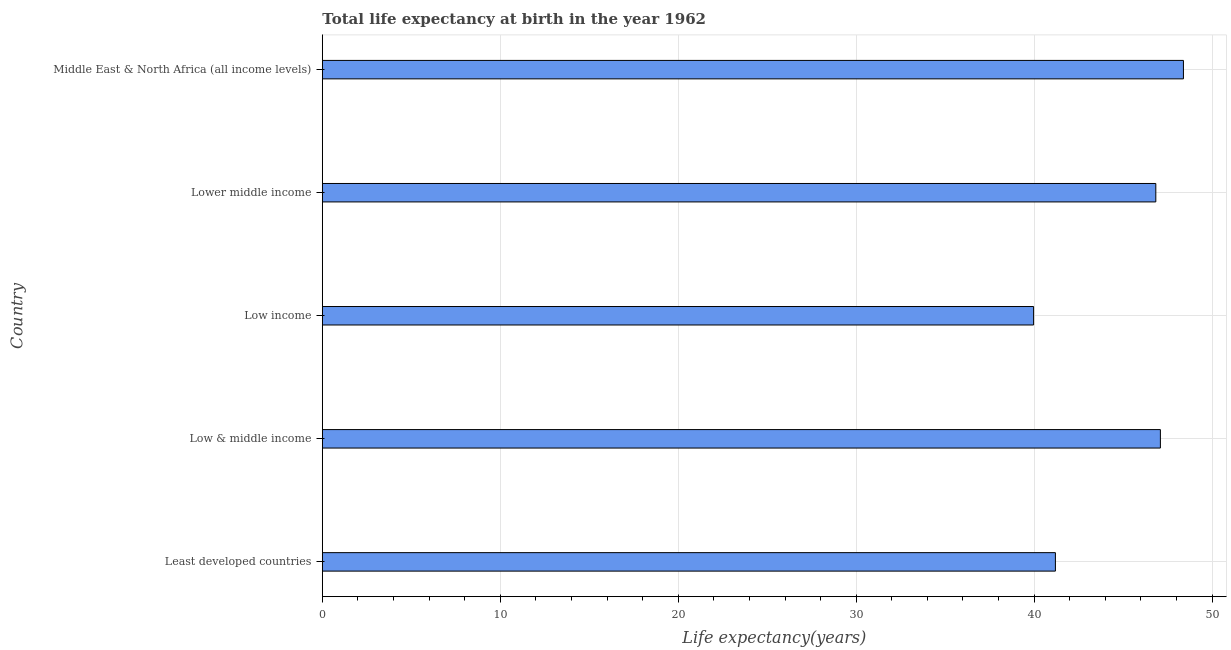Does the graph contain any zero values?
Offer a terse response. No. What is the title of the graph?
Your answer should be compact. Total life expectancy at birth in the year 1962. What is the label or title of the X-axis?
Offer a very short reply. Life expectancy(years). What is the life expectancy at birth in Middle East & North Africa (all income levels)?
Provide a short and direct response. 48.39. Across all countries, what is the maximum life expectancy at birth?
Your answer should be compact. 48.39. Across all countries, what is the minimum life expectancy at birth?
Ensure brevity in your answer.  39.97. In which country was the life expectancy at birth maximum?
Your response must be concise. Middle East & North Africa (all income levels). In which country was the life expectancy at birth minimum?
Offer a very short reply. Low income. What is the sum of the life expectancy at birth?
Your response must be concise. 223.47. What is the difference between the life expectancy at birth in Low & middle income and Middle East & North Africa (all income levels)?
Offer a very short reply. -1.29. What is the average life expectancy at birth per country?
Your answer should be very brief. 44.7. What is the median life expectancy at birth?
Your answer should be compact. 46.84. In how many countries, is the life expectancy at birth greater than 34 years?
Provide a succinct answer. 5. What is the ratio of the life expectancy at birth in Low income to that in Middle East & North Africa (all income levels)?
Keep it short and to the point. 0.83. What is the difference between the highest and the second highest life expectancy at birth?
Ensure brevity in your answer.  1.29. Is the sum of the life expectancy at birth in Low & middle income and Middle East & North Africa (all income levels) greater than the maximum life expectancy at birth across all countries?
Offer a very short reply. Yes. What is the difference between the highest and the lowest life expectancy at birth?
Offer a very short reply. 8.42. Are all the bars in the graph horizontal?
Offer a very short reply. Yes. How many countries are there in the graph?
Make the answer very short. 5. What is the difference between two consecutive major ticks on the X-axis?
Your answer should be very brief. 10. What is the Life expectancy(years) in Least developed countries?
Make the answer very short. 41.19. What is the Life expectancy(years) in Low & middle income?
Provide a succinct answer. 47.09. What is the Life expectancy(years) in Low income?
Ensure brevity in your answer.  39.97. What is the Life expectancy(years) of Lower middle income?
Give a very brief answer. 46.84. What is the Life expectancy(years) in Middle East & North Africa (all income levels)?
Provide a short and direct response. 48.39. What is the difference between the Life expectancy(years) in Least developed countries and Low & middle income?
Your answer should be very brief. -5.9. What is the difference between the Life expectancy(years) in Least developed countries and Low income?
Your answer should be very brief. 1.23. What is the difference between the Life expectancy(years) in Least developed countries and Lower middle income?
Your response must be concise. -5.64. What is the difference between the Life expectancy(years) in Least developed countries and Middle East & North Africa (all income levels)?
Give a very brief answer. -7.19. What is the difference between the Life expectancy(years) in Low & middle income and Low income?
Your answer should be very brief. 7.12. What is the difference between the Life expectancy(years) in Low & middle income and Lower middle income?
Your answer should be compact. 0.26. What is the difference between the Life expectancy(years) in Low & middle income and Middle East & North Africa (all income levels)?
Your response must be concise. -1.3. What is the difference between the Life expectancy(years) in Low income and Lower middle income?
Make the answer very short. -6.87. What is the difference between the Life expectancy(years) in Low income and Middle East & North Africa (all income levels)?
Provide a short and direct response. -8.42. What is the difference between the Life expectancy(years) in Lower middle income and Middle East & North Africa (all income levels)?
Provide a short and direct response. -1.55. What is the ratio of the Life expectancy(years) in Least developed countries to that in Low income?
Provide a short and direct response. 1.03. What is the ratio of the Life expectancy(years) in Least developed countries to that in Lower middle income?
Your answer should be compact. 0.88. What is the ratio of the Life expectancy(years) in Least developed countries to that in Middle East & North Africa (all income levels)?
Make the answer very short. 0.85. What is the ratio of the Life expectancy(years) in Low & middle income to that in Low income?
Your answer should be very brief. 1.18. What is the ratio of the Life expectancy(years) in Low & middle income to that in Middle East & North Africa (all income levels)?
Keep it short and to the point. 0.97. What is the ratio of the Life expectancy(years) in Low income to that in Lower middle income?
Your answer should be very brief. 0.85. What is the ratio of the Life expectancy(years) in Low income to that in Middle East & North Africa (all income levels)?
Your answer should be very brief. 0.83. 